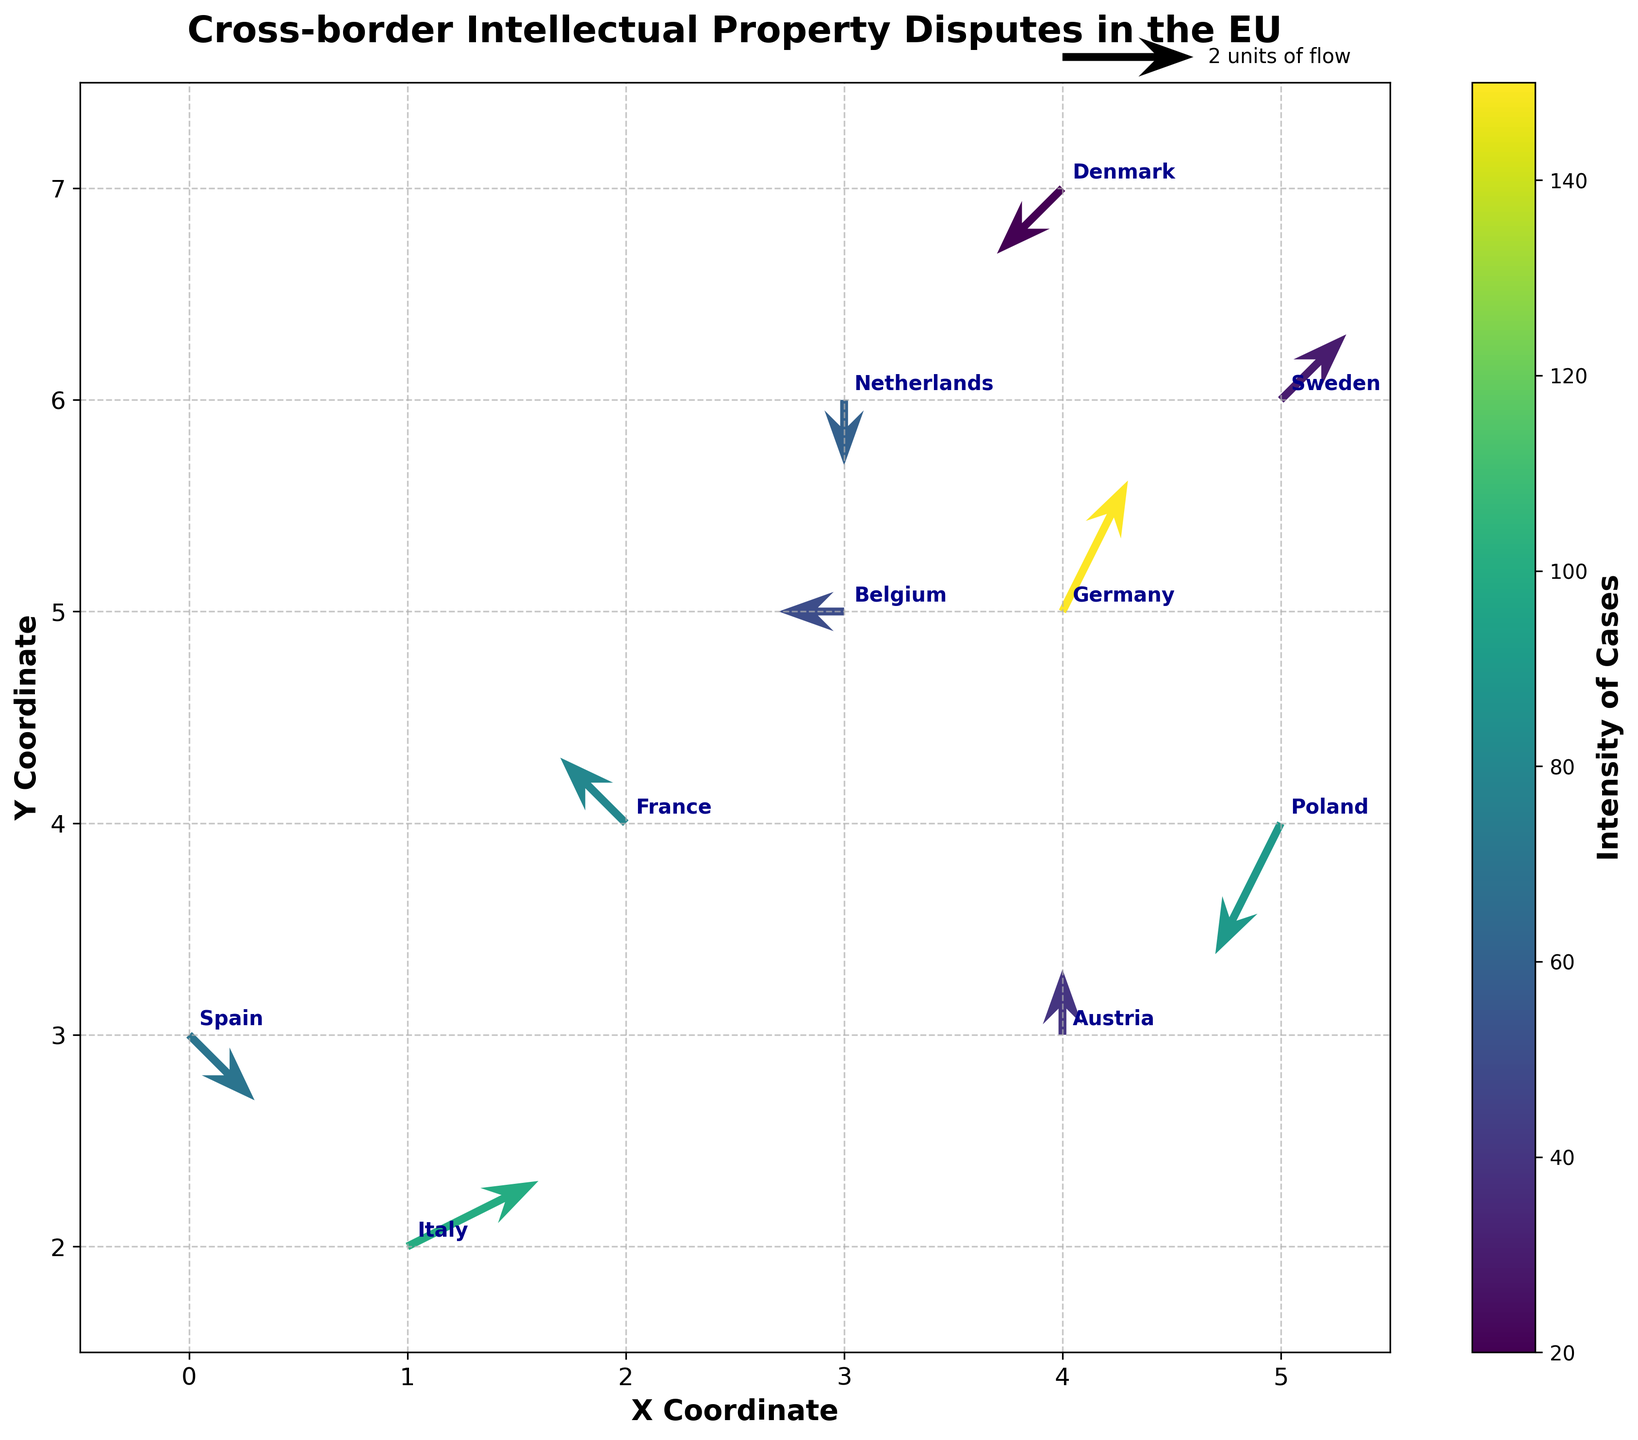Which country has the highest intensity of intellectual property disputes? The country with the highest intensity will be the one that has the darkest quiver arrow, as the intensity is mapped using a color gradient. Germany's arrow appears the darkest, indicating it has the highest intensity.
Answer: Germany What do the X and Y axes represent in this plot? The X and Y axes represent coordinates in a 2-dimensional space, possibly indicating a positional relationship among the countries used to visualize the direction and flow of intellectual property disputes.
Answer: X and Y coordinates What is the direction of IP dispute flow for France? The direction of the flow for France can be seen by the vector starting from France's coordinates and pointing to the direction indicated by the arrow. The vector for France points leftwards and upwards, so the direction is towards the northwest.
Answer: Northwest How does the number of cases in Poland compare to those in Austria? To compare, observe the color intensity of the vectors. Poland's vector is moderately intense while Austria's vector is lighter. The color bar shows Austria has fewer cases (intensity 40) compared to Poland (intensity 90).
Answer: Poland has more cases How many countries have a negative U component in their IP dispute vectors? A negative U component signifies leftward flow. By inspecting the U values or the direction of each vector, we find that France, Poland, Belgium, and Denmark (4 countries) have vectors pointing left.
Answer: 4 countries Which country shows no vertical movement in its IP dispute flow? Vertical movement corresponds to the V component. The country whose vector has V equal to 0 shows no vertical movement. Belgium's vector has V = 0, indicating no vertical movement.
Answer: Belgium Between Italy and Spain, which country shows a greater intensity of cases? Observing the color intensity of the vectors representing Italy and Spain, Italy's vector appears darker on the intensity color gradient than Spain's. According to the intensity values, Italy has an intensity of 100, while Spain has 70.
Answer: Italy What does the vector starting from Denmark indicate in terms of flow direction? The direction of the vector from Denmark can be observed by the arrow starting from Denmark's coordinates. The vector points leftward and downward, indicating a south-western flow.
Answer: South-western direction Which two countries have vectors with a horizontal component of zero? A horizontal component of zero implies the vectors have no left or right movement, only vertical. The vectors for Netherlands and Austria have U = 0, indicating purely vertical movement.
Answer: Netherlands and Austria 